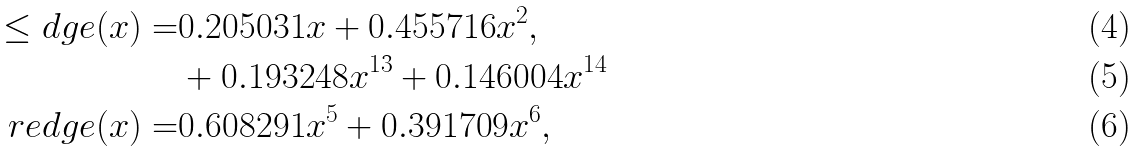Convert formula to latex. <formula><loc_0><loc_0><loc_500><loc_500>\leq d g e ( x ) = & 0 . 2 0 5 0 3 1 x + 0 . 4 5 5 7 1 6 x ^ { 2 } , \\ & + 0 . 1 9 3 2 4 8 x ^ { 1 3 } + 0 . 1 4 6 0 0 4 x ^ { 1 4 } \\ \ r e d g e ( x ) = & 0 . 6 0 8 2 9 1 x ^ { 5 } + 0 . 3 9 1 7 0 9 x ^ { 6 } ,</formula> 